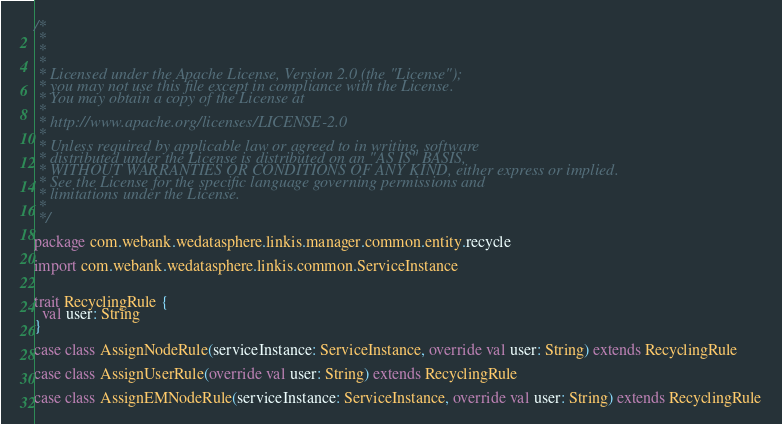<code> <loc_0><loc_0><loc_500><loc_500><_Scala_>/*
 *
 *
 *
 * Licensed under the Apache License, Version 2.0 (the "License");
 * you may not use this file except in compliance with the License.
 * You may obtain a copy of the License at
 *
 * http://www.apache.org/licenses/LICENSE-2.0
 *
 * Unless required by applicable law or agreed to in writing, software
 * distributed under the License is distributed on an "AS IS" BASIS,
 * WITHOUT WARRANTIES OR CONDITIONS OF ANY KIND, either express or implied.
 * See the License for the specific language governing permissions and
 * limitations under the License.
 *
 */

package com.webank.wedatasphere.linkis.manager.common.entity.recycle

import com.webank.wedatasphere.linkis.common.ServiceInstance


trait RecyclingRule {
  val user: String
}

case class AssignNodeRule(serviceInstance: ServiceInstance, override val user: String) extends RecyclingRule

case class AssignUserRule(override val user: String) extends RecyclingRule

case class AssignEMNodeRule(serviceInstance: ServiceInstance, override val user: String) extends RecyclingRule
</code> 